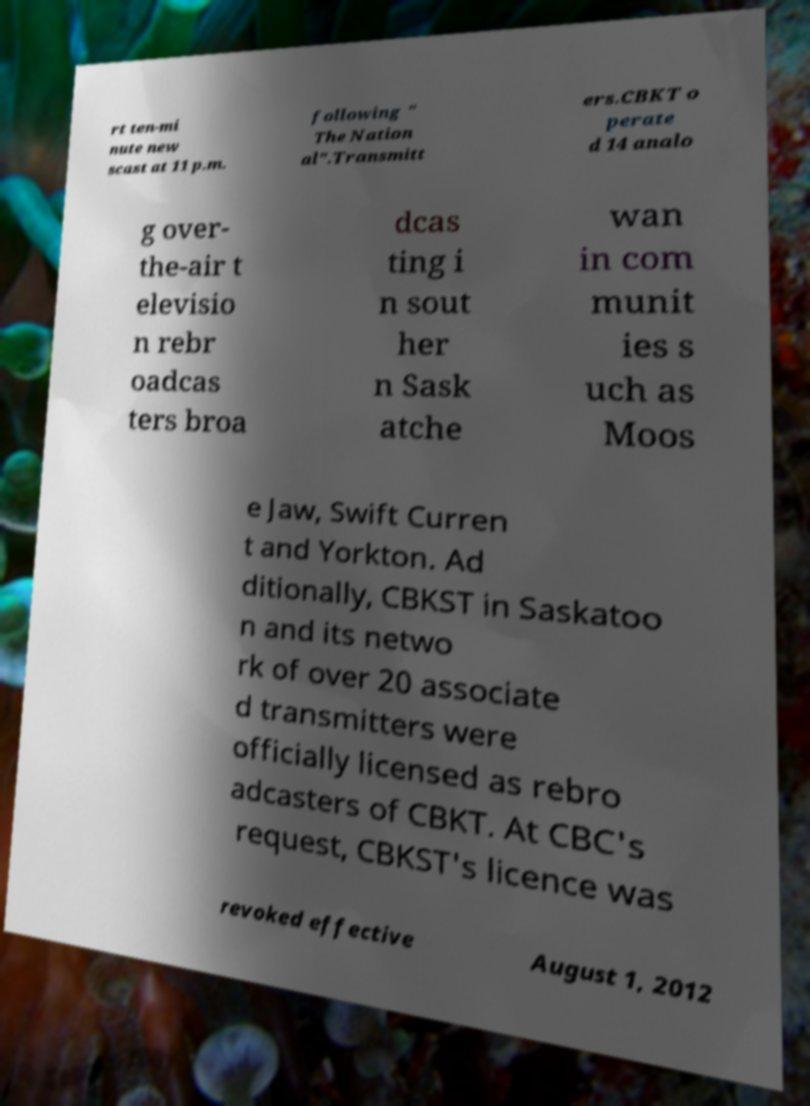For documentation purposes, I need the text within this image transcribed. Could you provide that? rt ten-mi nute new scast at 11 p.m. following " The Nation al".Transmitt ers.CBKT o perate d 14 analo g over- the-air t elevisio n rebr oadcas ters broa dcas ting i n sout her n Sask atche wan in com munit ies s uch as Moos e Jaw, Swift Curren t and Yorkton. Ad ditionally, CBKST in Saskatoo n and its netwo rk of over 20 associate d transmitters were officially licensed as rebro adcasters of CBKT. At CBC's request, CBKST's licence was revoked effective August 1, 2012 